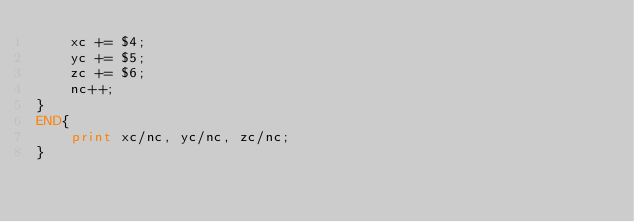Convert code to text. <code><loc_0><loc_0><loc_500><loc_500><_Awk_>    xc += $4;
    yc += $5;
    zc += $6;
    nc++;
}
END{
    print xc/nc, yc/nc, zc/nc;
}

</code> 